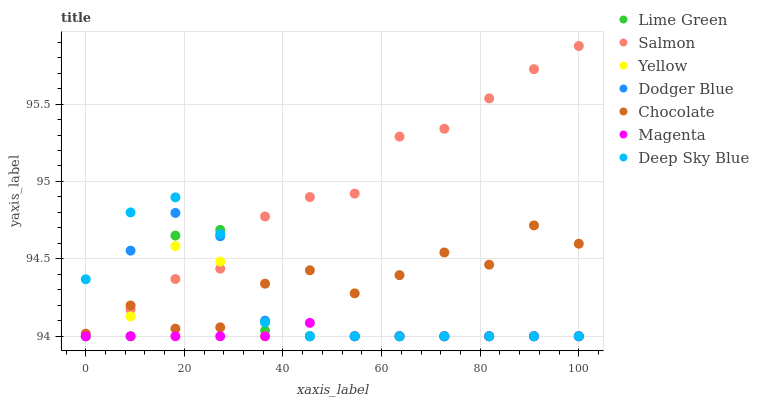Does Magenta have the minimum area under the curve?
Answer yes or no. Yes. Does Salmon have the maximum area under the curve?
Answer yes or no. Yes. Does Yellow have the minimum area under the curve?
Answer yes or no. No. Does Yellow have the maximum area under the curve?
Answer yes or no. No. Is Magenta the smoothest?
Answer yes or no. Yes. Is Lime Green the roughest?
Answer yes or no. Yes. Is Yellow the smoothest?
Answer yes or no. No. Is Yellow the roughest?
Answer yes or no. No. Does Salmon have the lowest value?
Answer yes or no. Yes. Does Chocolate have the lowest value?
Answer yes or no. No. Does Salmon have the highest value?
Answer yes or no. Yes. Does Yellow have the highest value?
Answer yes or no. No. Is Magenta less than Chocolate?
Answer yes or no. Yes. Is Chocolate greater than Magenta?
Answer yes or no. Yes. Does Chocolate intersect Yellow?
Answer yes or no. Yes. Is Chocolate less than Yellow?
Answer yes or no. No. Is Chocolate greater than Yellow?
Answer yes or no. No. Does Magenta intersect Chocolate?
Answer yes or no. No. 